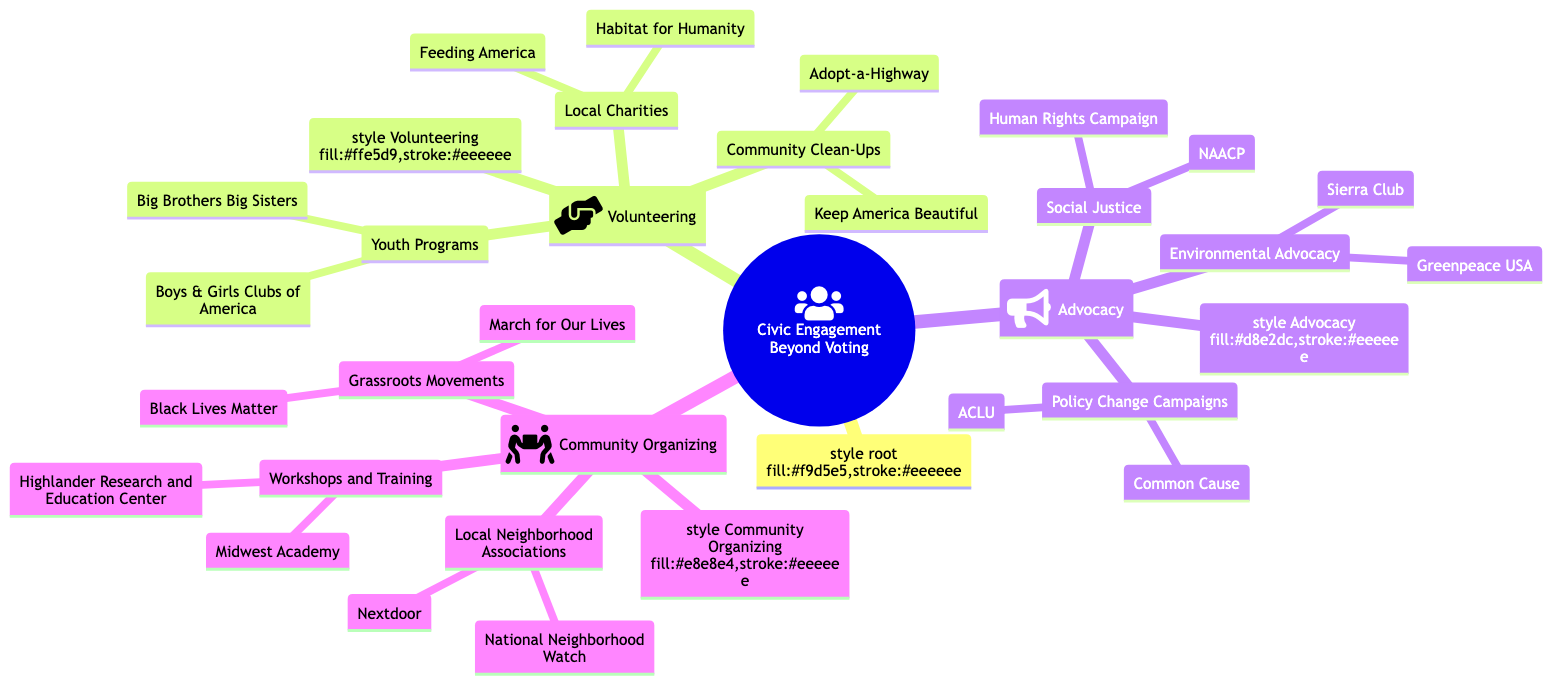What are two examples of local charities listed under Volunteering? Under the Volunteering category, there are two subcategories: Local Charities and Youth Programs. The diagram provides examples under Local Charities, specifically "Feeding America" and "Habitat for Humanity."
Answer: Feeding America, Habitat for Humanity How many main categories are there in the diagram? The diagram has three main categories: Volunteering, Advocacy, and Community Organizing. By counting the primary branches directly under the root node, we can determine this amount.
Answer: 3 Which organization is listed under Environmental Advocacy? Under the Advocacy category, there is a subcategory titled Environmental Advocacy. The diagram provides "Sierra Club" and "Greenpeace USA" as the organizations mentioned in this subcategory. Picking either of these as an answer is correct, and I will choose "Sierra Club" as it is the first one listed.
Answer: Sierra Club What type of activities are included in Community Clean-Ups? In the Volunteering section, we see that Community Clean-Ups is listed as a subcategory. The diagram specifies two examples: "Keep America Beautiful" and "Adopt-a-Highway." These activities fall under the general theme of community clean-up initiatives.
Answer: Keep America Beautiful, Adopt-a-Highway Which grassroots movement is represented in the diagram? The diagram under the Community Organizing category includes the subcategory Grassroots Movements, which lists "Black Lives Matter" and "March for Our Lives." Either of these movements can be named as an answer to this question. I will choose "Black Lives Matter" as it is the first one listed.
Answer: Black Lives Matter What organization focuses on policy change campaigns? Under the Advocacy category, there's a subcategory titled Policy Change Campaigns, which includes "ACLU" and "Common Cause." We can identify "ACLU" as one organization that specifically focuses on policy change campaigns.
Answer: ACLU How is community organizing depicted in the diagram? Community Organizing is one of the main categories in the diagram. It encompasses three subcategories: Local Neighborhood Associations, Grassroots Movements, and Workshops and Training. Each subcategory represents different forms of community organizing activities.
Answer: Local Neighborhood Associations, Grassroots Movements, Workshops and Training What does the icon for Advocacy represent? The diagram uses a specific icon for the Advocacy category, which is a bullhorn icon. This icon is chosen to symbolize advocacy efforts and activism. It visually indicates that this section is focused on societal issues and campaigns aimed at creating change.
Answer: Bullhorn 